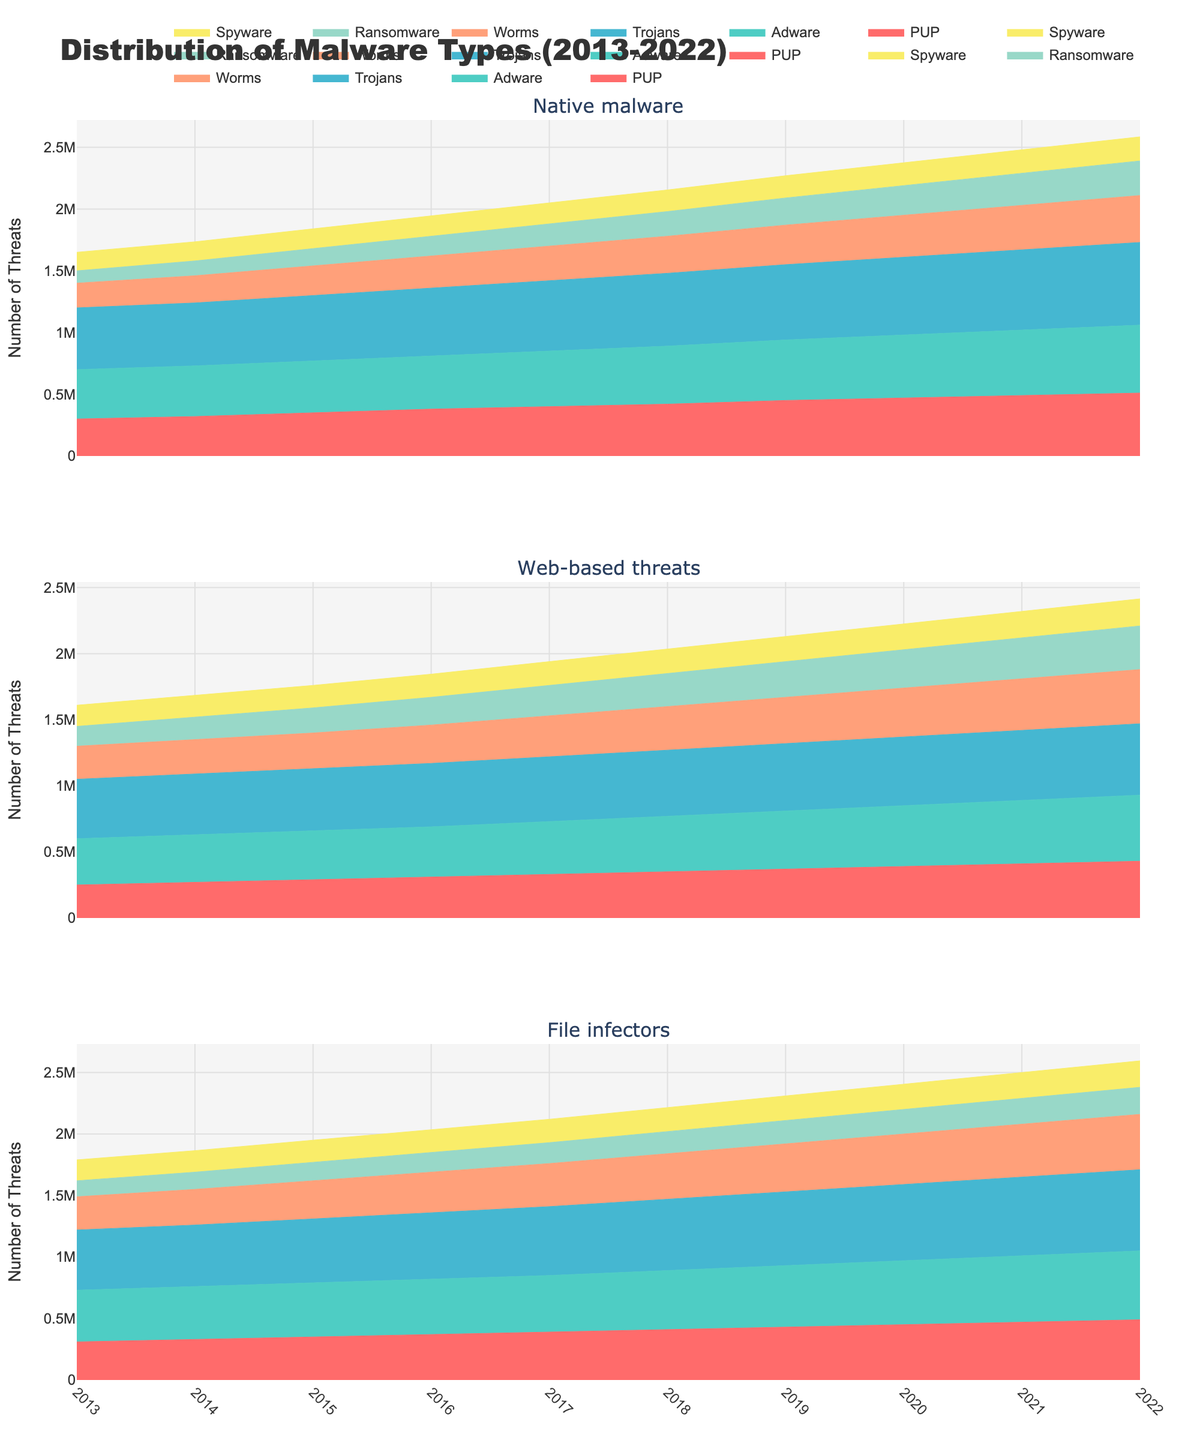What's the title of the figure? The title of a figure is generally located at the top center and provides an overview of what the figure represents. In this case, it is depicted prominently in larger font than other text.
Answer: Distribution of Malware Types (2013-2022) How many subplots are in the figure? The figure is separated into different sections called subplots. In this case, you must count the number of distinct rows of area charts displayed. There are three distinct sections.
Answer: 3 Which type of malware saw the highest number of threats in 2022? In 2022, the topmost line in the area chart for each subplot represents the cumulative total from all threat types. By identifying which subplot’s line is the highest, you can determine the malware type with the greatest threats.
Answer: File infectors How did the number of PUP threats for 'Web-based threats' change from 2013 to 2022? Observe the 'Web-based threats' subplot and look at the PUP layer, specifically its height over the years. The line representing PUP is the bottommost layer. Compare the initial point in 2013 with the final point in 2022 to assess the trend.
Answer: Increased Compare the number of Ransomware threats for 'Native malware' and 'Web-based threats' in 2020. Which was higher? First, locate the year 2020 on the x-axis. Then, compare the height of the Ransomware layers, which is near the top, in the 'Native malware' and 'Web-based threats' subplots. The higher layer indicates a greater number of threats.
Answer: Web-based threats What is the trend in the number of Spyware threats for 'File infectors' from 2013 to 2022? Look at the 'File infectors' subplot and specifically observe the Spyware layer at the top. Trace its height from 2013 to 2022 to identify whether it generally increases, decreases, or remains stable.
Answer: Increased Which year had the highest total number of threats for 'Native malware'? In the 'Native malware' subplot, identify the year where the top of the combined layers reaches its highest point, indicating the year with the most threats.
Answer: 2022 What's the difference in the number of Worms threats for 'File infectors' between 2018 and 2019? Determine the height of the Worms layer (fourth from the bottom) in the 'File infectors' subplot for both years, then subtract the 2018 value from the 2019 value to find the difference.
Answer: 20,000 What is the general trend for Adware threats across all malware types over the decade? Examine the Adware layers in all three subplots over the timeframe from 2013 to 2022. Identify whether they show a general increase, decrease, or fluctuation throughout the decade.
Answer: Increased In 2016, which type of malware had the highest number of Trojans threats? Look at the year 2016 across all three subplots and focus on the height of the Trojans layers (third from the bottom). The malware type with the highest layer represents the maximum number of Trojans threats for that year.
Answer: File infectors 